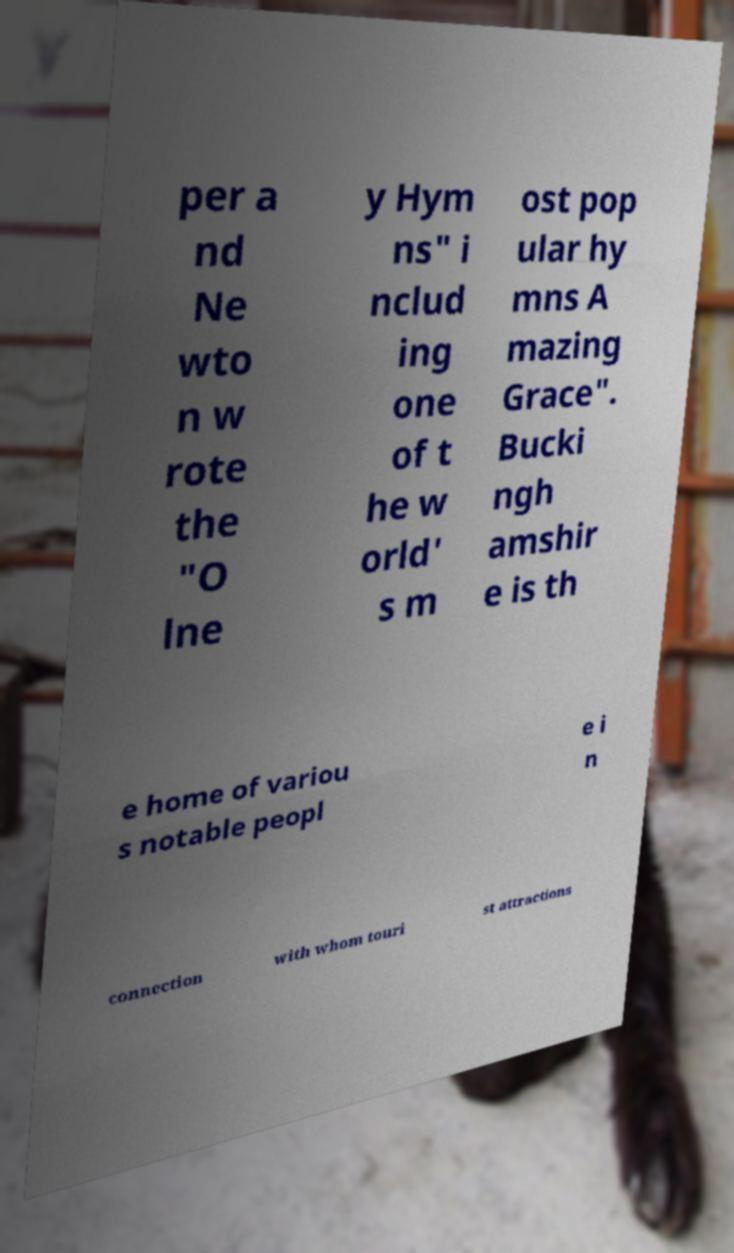Can you accurately transcribe the text from the provided image for me? per a nd Ne wto n w rote the "O lne y Hym ns" i nclud ing one of t he w orld' s m ost pop ular hy mns A mazing Grace". Bucki ngh amshir e is th e home of variou s notable peopl e i n connection with whom touri st attractions 